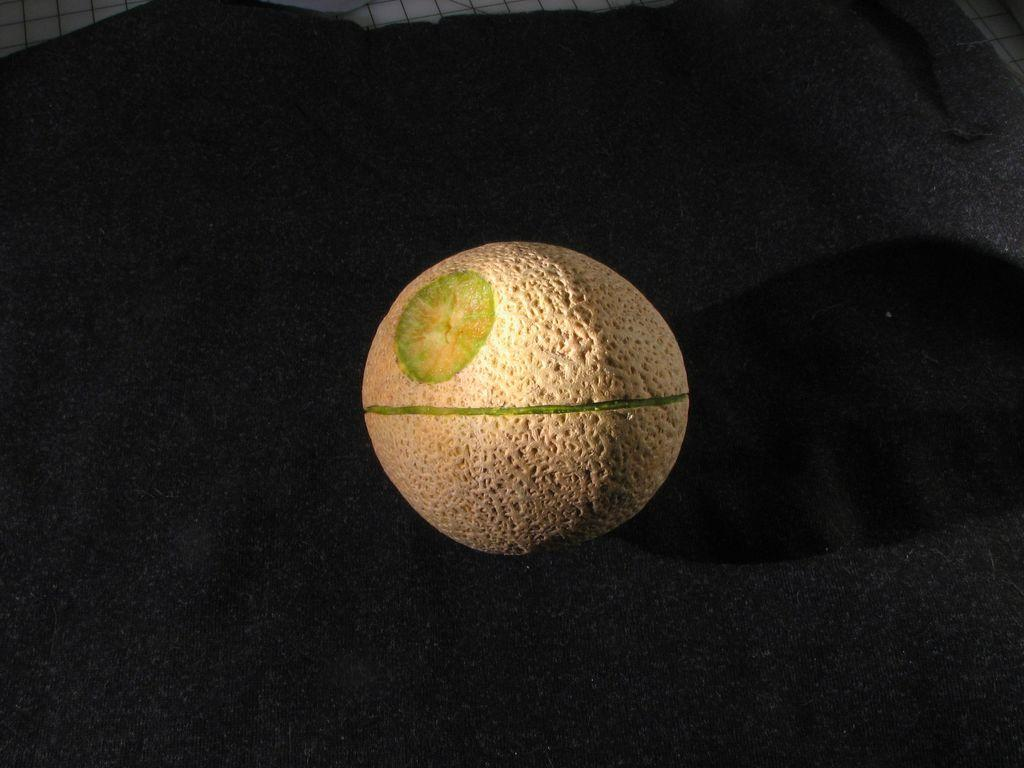What is the shape of the main object in the image? The main object in the image is round shaped. What color is present on the round shaped object? The round shaped object has a green color line on it. What is the color of the surface on which the round shaped object is placed? The round shaped object is on a black color surface. How is the coat tied in the image? There is no coat present in the image. What type of knot is used to secure the round shaped object in the image? The round shaped object is not tied or secured with a knot in the image. 